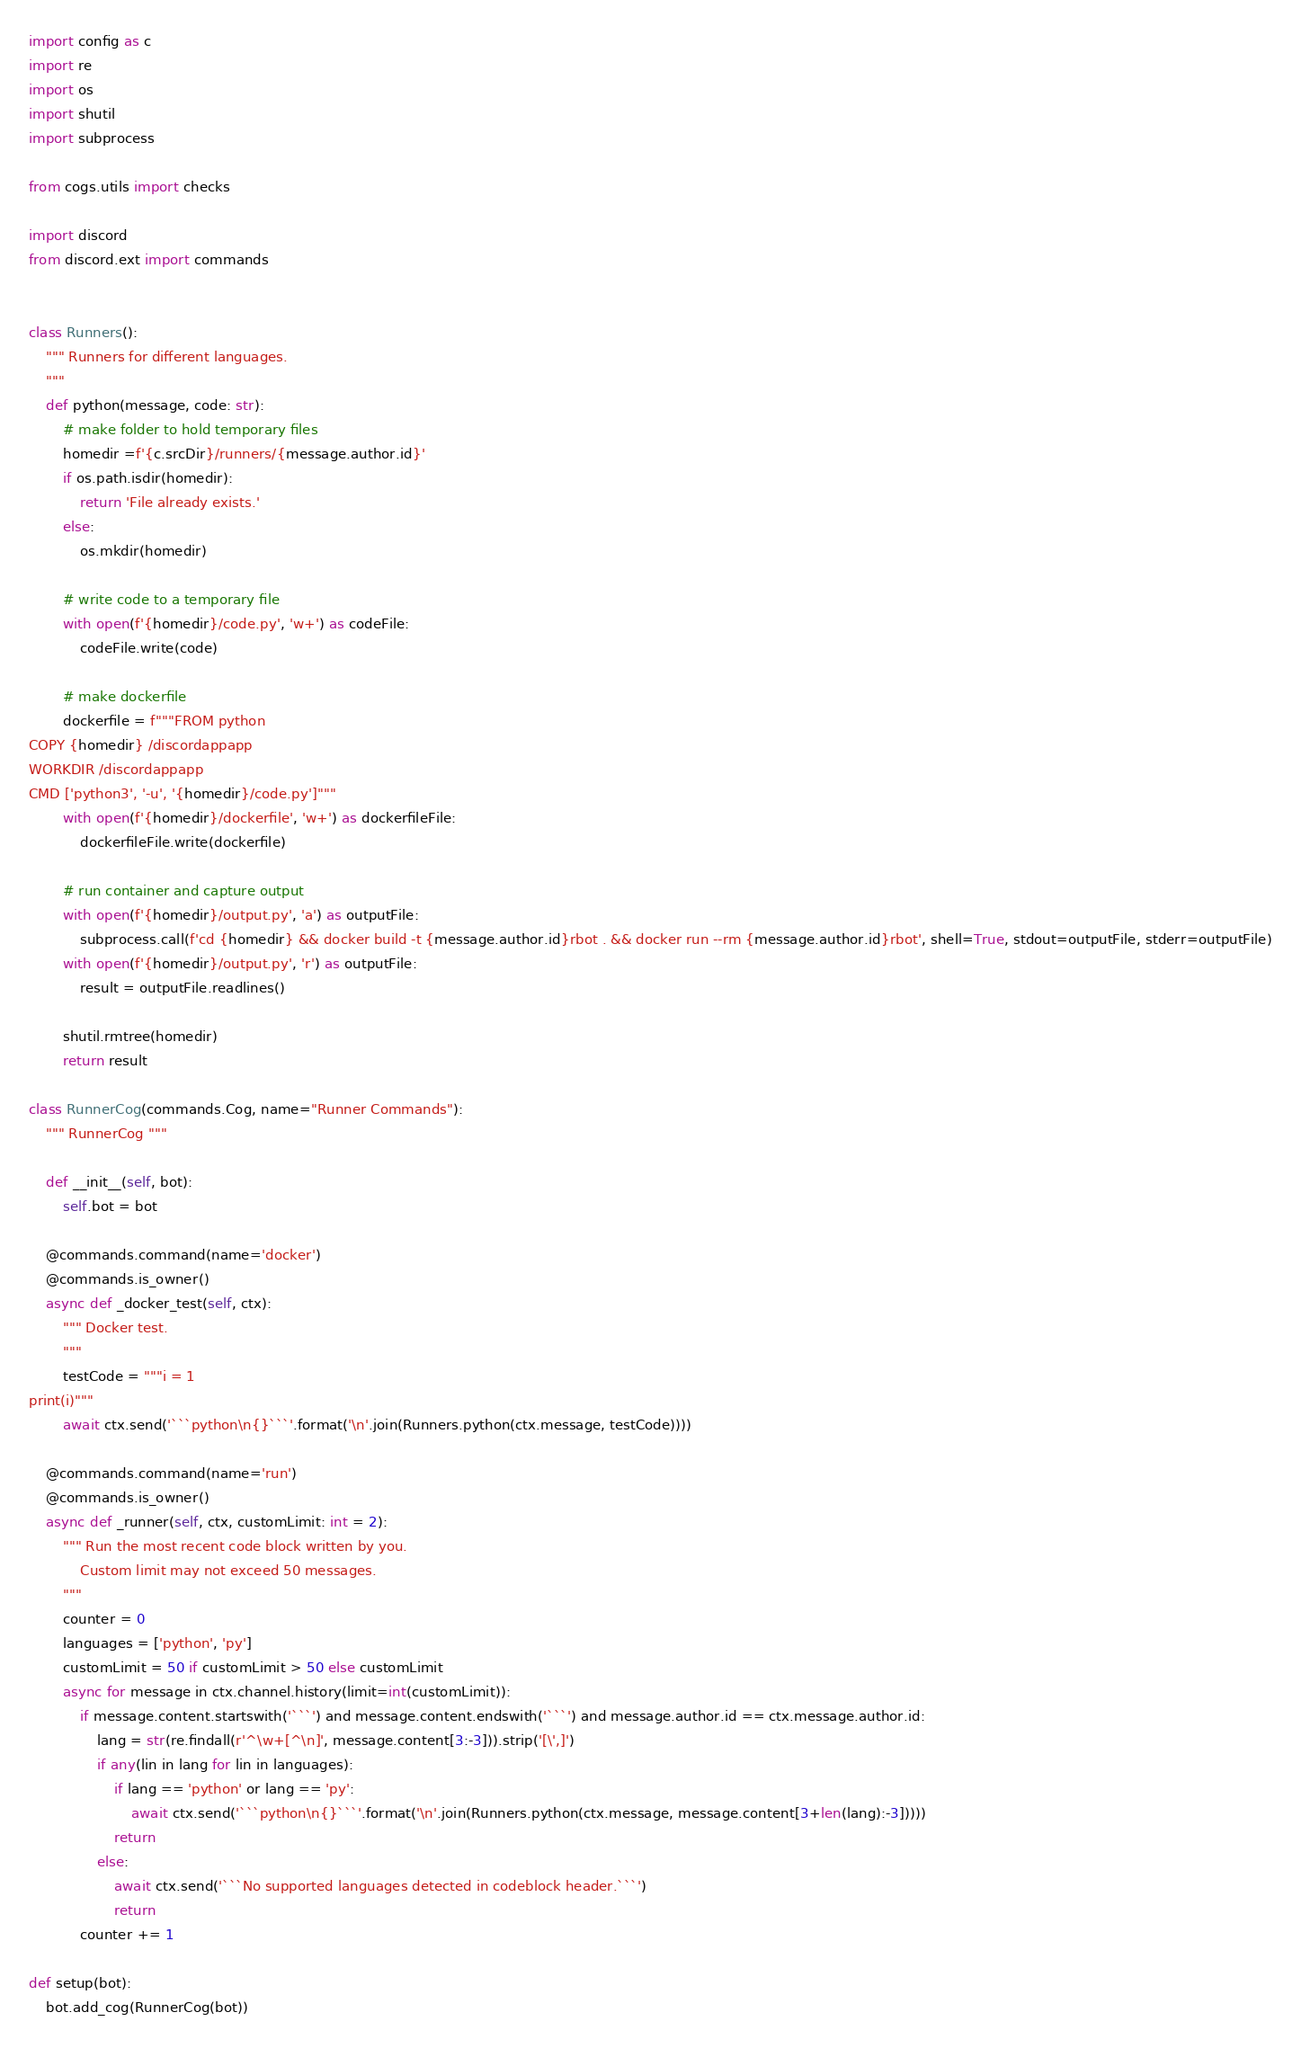Convert code to text. <code><loc_0><loc_0><loc_500><loc_500><_Python_>import config as c
import re
import os
import shutil
import subprocess

from cogs.utils import checks

import discord
from discord.ext import commands


class Runners():
    """ Runners for different languages.
    """
    def python(message, code: str):
        # make folder to hold temporary files
        homedir =f'{c.srcDir}/runners/{message.author.id}'
        if os.path.isdir(homedir):
            return 'File already exists.'
        else:
            os.mkdir(homedir)

        # write code to a temporary file
        with open(f'{homedir}/code.py', 'w+') as codeFile:
            codeFile.write(code)

        # make dockerfile
        dockerfile = f"""FROM python
COPY {homedir} /discordappapp
WORKDIR /discordappapp
CMD ['python3', '-u', '{homedir}/code.py']"""
        with open(f'{homedir}/dockerfile', 'w+') as dockerfileFile:
            dockerfileFile.write(dockerfile)

        # run container and capture output
        with open(f'{homedir}/output.py', 'a') as outputFile:
            subprocess.call(f'cd {homedir} && docker build -t {message.author.id}rbot . && docker run --rm {message.author.id}rbot', shell=True, stdout=outputFile, stderr=outputFile)
        with open(f'{homedir}/output.py', 'r') as outputFile:
            result = outputFile.readlines()

        shutil.rmtree(homedir)
        return result

class RunnerCog(commands.Cog, name="Runner Commands"):
    """ RunnerCog """

    def __init__(self, bot):
        self.bot = bot

    @commands.command(name='docker')
    @commands.is_owner()
    async def _docker_test(self, ctx):
        """ Docker test.
        """
        testCode = """i = 1
print(i)"""
        await ctx.send('```python\n{}```'.format('\n'.join(Runners.python(ctx.message, testCode))))

    @commands.command(name='run')
    @commands.is_owner()
    async def _runner(self, ctx, customLimit: int = 2):
        """ Run the most recent code block written by you.
            Custom limit may not exceed 50 messages.
        """
        counter = 0
        languages = ['python', 'py']
        customLimit = 50 if customLimit > 50 else customLimit
        async for message in ctx.channel.history(limit=int(customLimit)):
            if message.content.startswith('```') and message.content.endswith('```') and message.author.id == ctx.message.author.id:
                lang = str(re.findall(r'^\w+[^\n]', message.content[3:-3])).strip('[\',]')
                if any(lin in lang for lin in languages):
                    if lang == 'python' or lang == 'py':
                        await ctx.send('```python\n{}```'.format('\n'.join(Runners.python(ctx.message, message.content[3+len(lang):-3]))))
                    return
                else:
                    await ctx.send('```No supported languages detected in codeblock header.```')
                    return
            counter += 1

def setup(bot):
    bot.add_cog(RunnerCog(bot))
</code> 